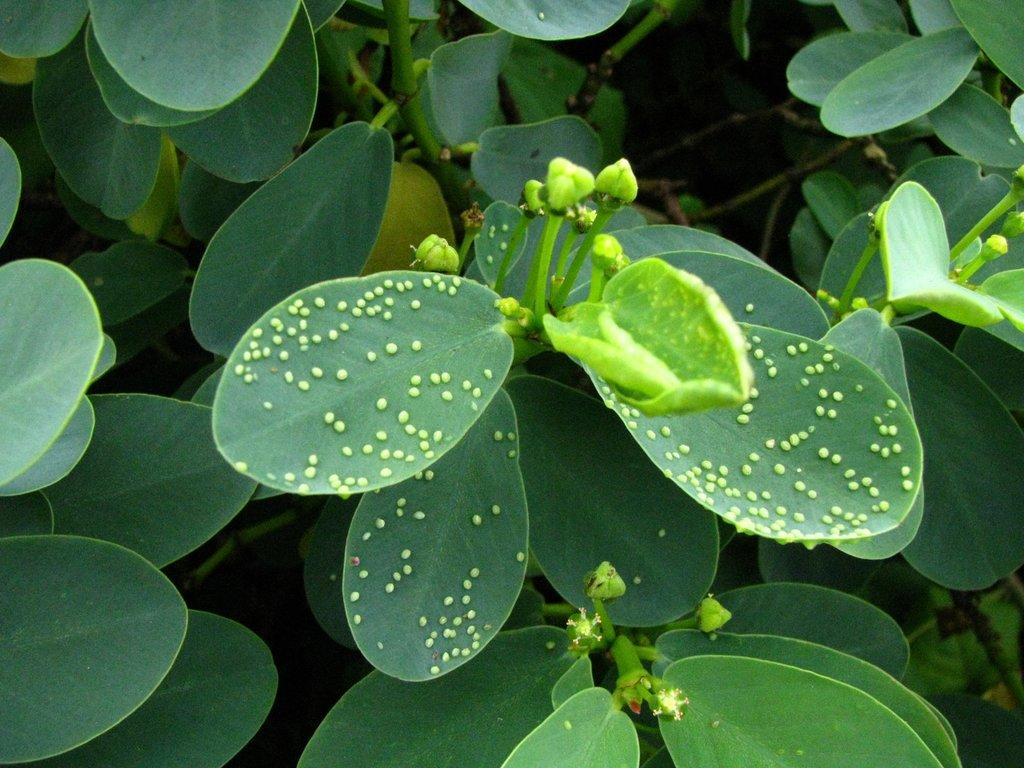What is located in the foreground of the image? There are plants in the foreground of the image. What stage of growth are the plants in? There are buds on the plants in the foreground, indicating that they are in the process of blooming. What type of park can be seen in the background of the image? There is no park visible in the image; it only features plants in the foreground. What is the size of the plants in the image? The size of the plants cannot be determined from the image alone, as there is no reference point for comparison. 